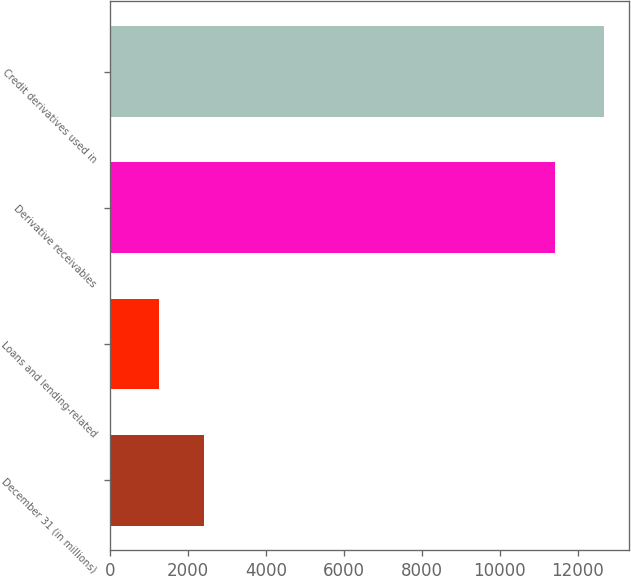<chart> <loc_0><loc_0><loc_500><loc_500><bar_chart><fcel>December 31 (in millions)<fcel>Loans and lending-related<fcel>Derivative receivables<fcel>Credit derivatives used in<nl><fcel>2413<fcel>1272<fcel>11410<fcel>12682<nl></chart> 